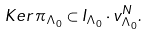Convert formula to latex. <formula><loc_0><loc_0><loc_500><loc_500>K e r \, \pi _ { \Lambda _ { 0 } } \subset I _ { \Lambda _ { 0 } } \cdot v _ { \Lambda _ { 0 } } ^ { N } .</formula> 